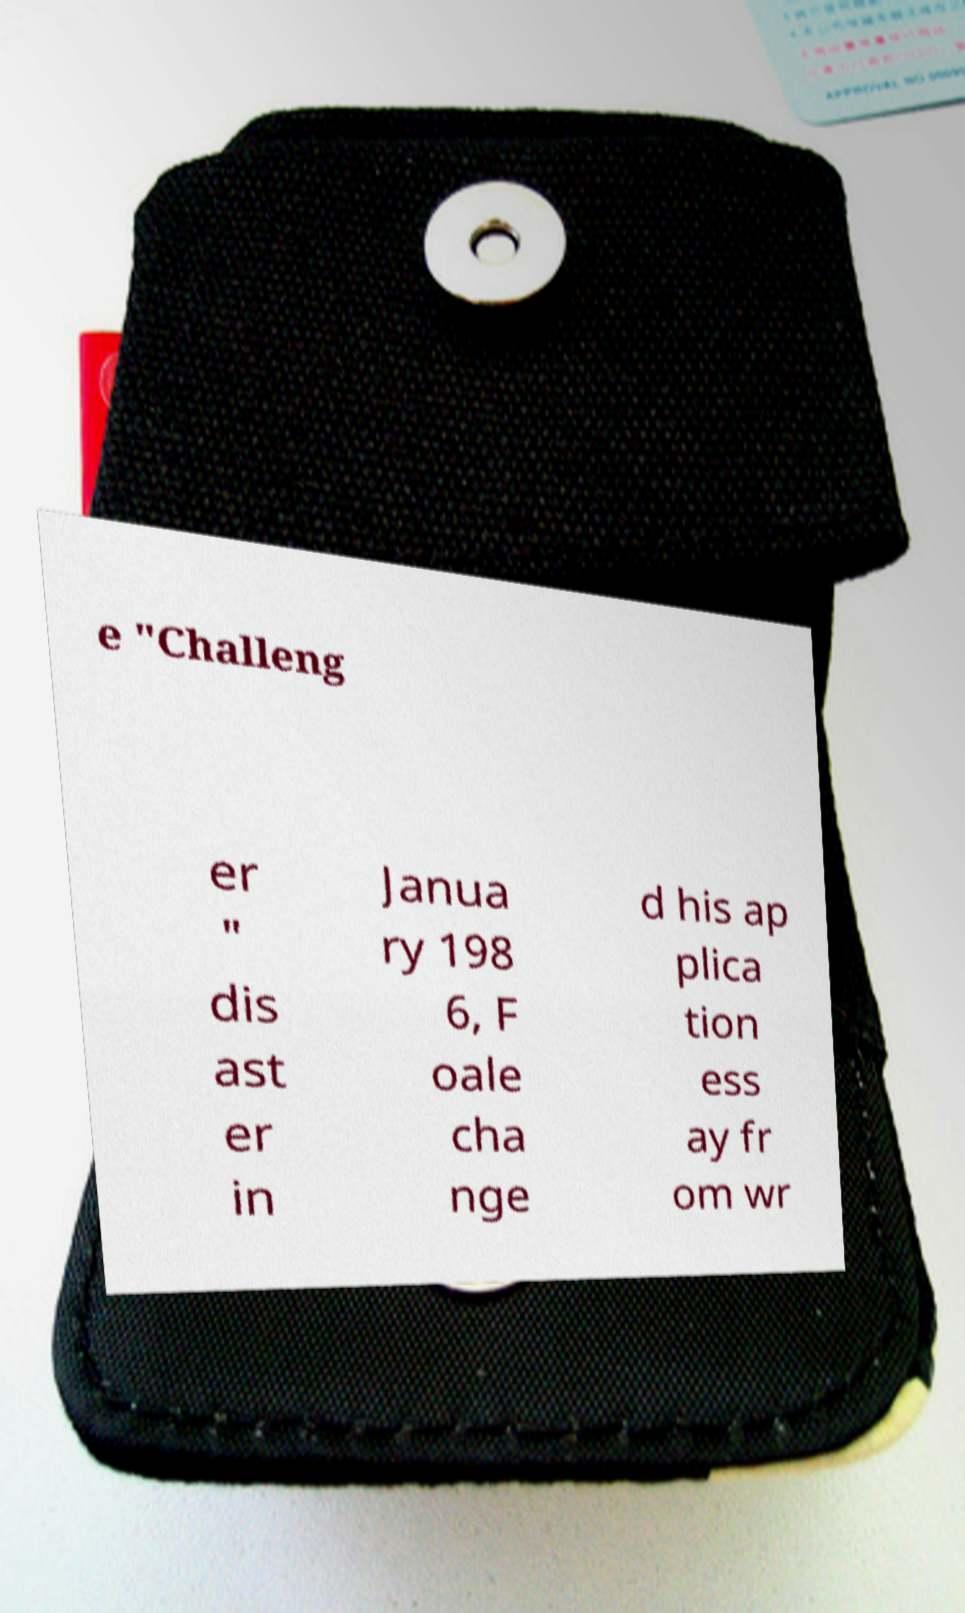Can you read and provide the text displayed in the image?This photo seems to have some interesting text. Can you extract and type it out for me? e "Challeng er " dis ast er in Janua ry 198 6, F oale cha nge d his ap plica tion ess ay fr om wr 